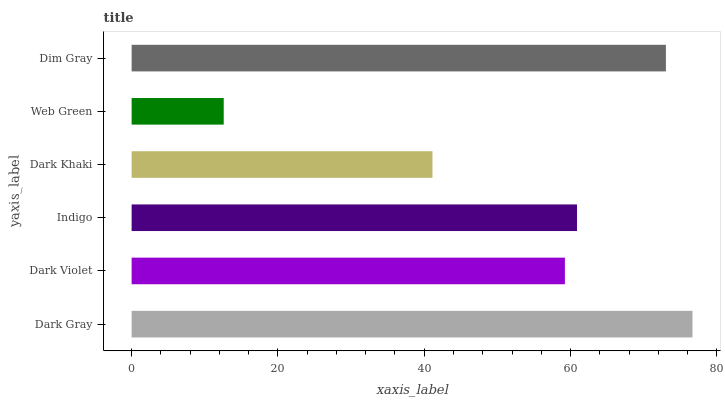Is Web Green the minimum?
Answer yes or no. Yes. Is Dark Gray the maximum?
Answer yes or no. Yes. Is Dark Violet the minimum?
Answer yes or no. No. Is Dark Violet the maximum?
Answer yes or no. No. Is Dark Gray greater than Dark Violet?
Answer yes or no. Yes. Is Dark Violet less than Dark Gray?
Answer yes or no. Yes. Is Dark Violet greater than Dark Gray?
Answer yes or no. No. Is Dark Gray less than Dark Violet?
Answer yes or no. No. Is Indigo the high median?
Answer yes or no. Yes. Is Dark Violet the low median?
Answer yes or no. Yes. Is Dark Khaki the high median?
Answer yes or no. No. Is Dark Gray the low median?
Answer yes or no. No. 